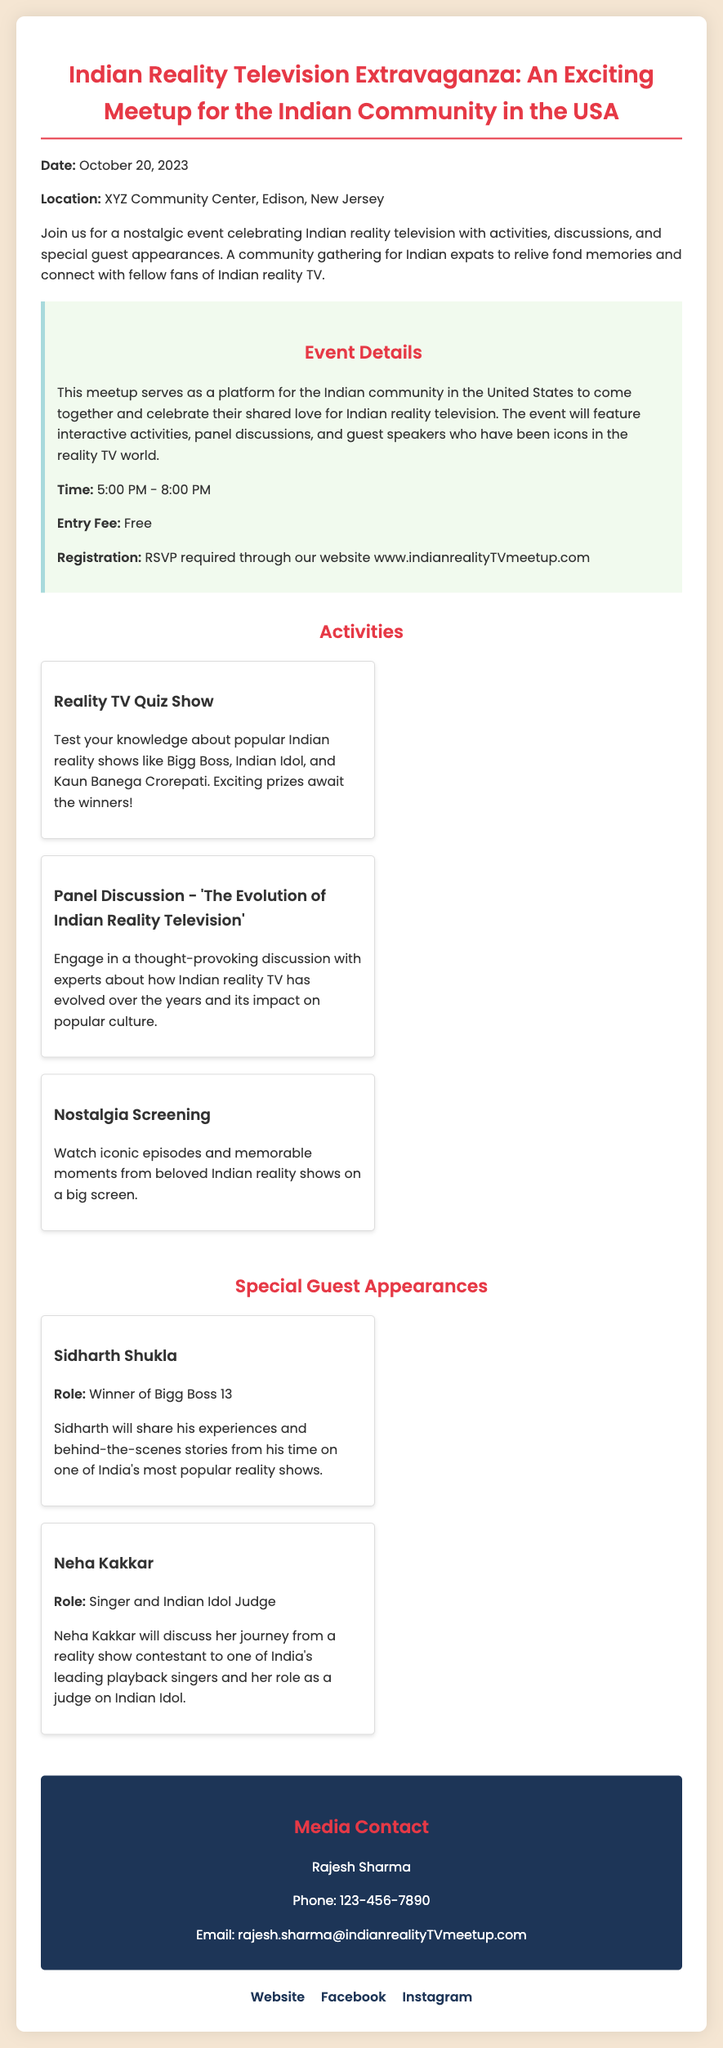What is the date of the event? The date of the event is mentioned in the document as October 20, 2023.
Answer: October 20, 2023 Where is the event being held? The location of the event is specified as XYZ Community Center, Edison, New Jersey.
Answer: XYZ Community Center, Edison, New Jersey What is the entry fee for the event? The entry fee is stated clearly in the document as free.
Answer: Free Who is one of the special guests attending? The document lists Sidharth Shukla as one of the special guests.
Answer: Sidharth Shukla What time will the event start? The starting time for the event is mentioned as 5:00 PM.
Answer: 5:00 PM What type of discussion is planned for the event? The document describes a panel discussion about the evolution of Indian reality television.
Answer: 'The Evolution of Indian Reality Television' How can people register for the event? The registration details indicate that RSVP is required through the website.
Answer: RSVP required through the website What is one of the activities mentioned at the event? The document includes a reality TV quiz show as one of the activities.
Answer: Reality TV Quiz Show Who will discuss their journey as a judge on Indian Idol? Neha Kakkar is mentioned as discussing her journey as a judge on Indian Idol.
Answer: Neha Kakkar 